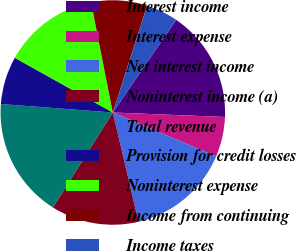<chart> <loc_0><loc_0><loc_500><loc_500><pie_chart><fcel>Interest income<fcel>Interest expense<fcel>Net interest income<fcel>Noninterest income (a)<fcel>Total revenue<fcel>Provision for credit losses<fcel>Noninterest expense<fcel>Income from continuing<fcel>Income taxes<nl><fcel>16.09%<fcel>5.75%<fcel>14.94%<fcel>12.64%<fcel>17.24%<fcel>6.9%<fcel>13.79%<fcel>8.05%<fcel>4.6%<nl></chart> 